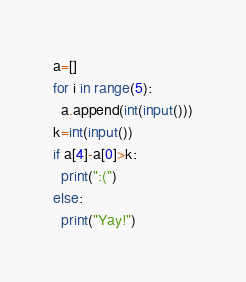<code> <loc_0><loc_0><loc_500><loc_500><_Python_>a=[]
for i in range(5):
  a.append(int(input()))
k=int(input())
if a[4]-a[0]>k:
  print(":(")
else:
  print("Yay!")</code> 